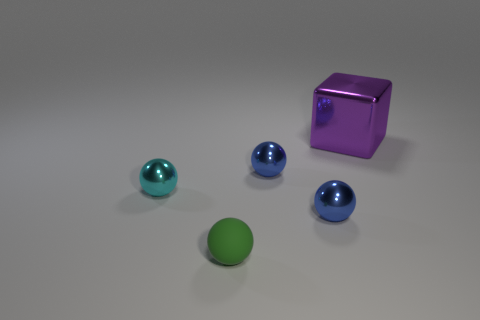Are there any other things that have the same shape as the matte object?
Your response must be concise. Yes. What color is the other small matte object that is the same shape as the cyan object?
Provide a succinct answer. Green. How many objects are tiny blue things that are in front of the cyan shiny thing or blue cylinders?
Provide a short and direct response. 1. How many objects are either large blue rubber objects or metal objects in front of the purple metal object?
Provide a short and direct response. 3. There is a tiny blue thing in front of the tiny object that is behind the cyan ball; how many metal balls are behind it?
Your response must be concise. 2. There is a cyan object that is the same size as the matte sphere; what material is it?
Provide a succinct answer. Metal. Are there any cyan balls of the same size as the purple shiny object?
Provide a short and direct response. No. What color is the large object?
Provide a short and direct response. Purple. What color is the tiny object left of the small green matte sphere that is in front of the small cyan shiny sphere?
Provide a short and direct response. Cyan. What shape is the object behind the small ball behind the metallic ball that is left of the small green sphere?
Offer a very short reply. Cube. 